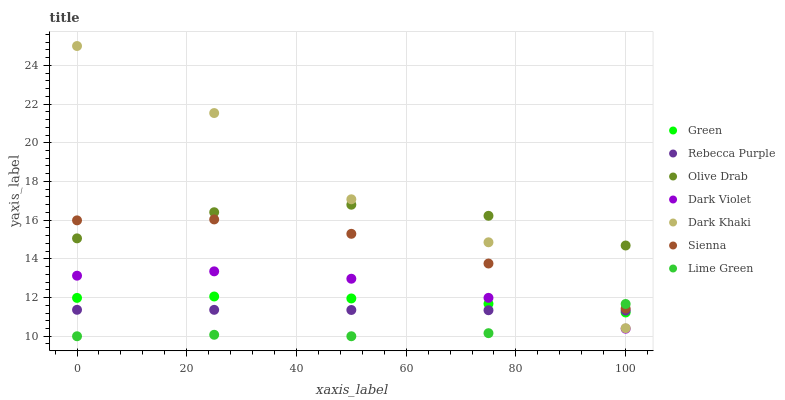Does Lime Green have the minimum area under the curve?
Answer yes or no. Yes. Does Dark Khaki have the maximum area under the curve?
Answer yes or no. Yes. Does Dark Violet have the minimum area under the curve?
Answer yes or no. No. Does Dark Violet have the maximum area under the curve?
Answer yes or no. No. Is Rebecca Purple the smoothest?
Answer yes or no. Yes. Is Dark Khaki the roughest?
Answer yes or no. Yes. Is Dark Violet the smoothest?
Answer yes or no. No. Is Dark Violet the roughest?
Answer yes or no. No. Does Lime Green have the lowest value?
Answer yes or no. Yes. Does Dark Violet have the lowest value?
Answer yes or no. No. Does Dark Khaki have the highest value?
Answer yes or no. Yes. Does Dark Violet have the highest value?
Answer yes or no. No. Is Green less than Sienna?
Answer yes or no. Yes. Is Olive Drab greater than Dark Violet?
Answer yes or no. Yes. Does Dark Violet intersect Rebecca Purple?
Answer yes or no. Yes. Is Dark Violet less than Rebecca Purple?
Answer yes or no. No. Is Dark Violet greater than Rebecca Purple?
Answer yes or no. No. Does Green intersect Sienna?
Answer yes or no. No. 